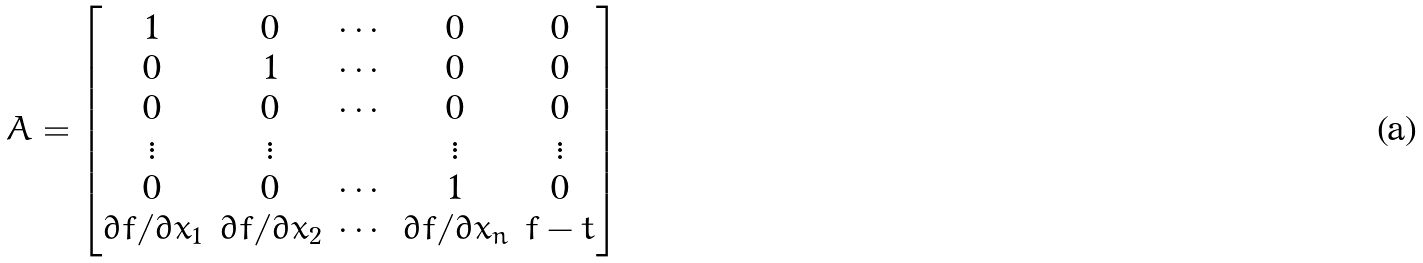Convert formula to latex. <formula><loc_0><loc_0><loc_500><loc_500>A = \begin{bmatrix} 1 & 0 & \cdots & 0 & 0 \\ 0 & 1 & \cdots & 0 & 0 \\ 0 & 0 & \cdots & 0 & 0 \\ \vdots & \vdots & & \vdots & \vdots \\ 0 & 0 & \cdots & 1 & 0 \\ \partial f / \partial x _ { 1 } & \partial f / \partial x _ { 2 } & \cdots & \partial f / \partial x _ { n } & f - t \\ \end{bmatrix}</formula> 